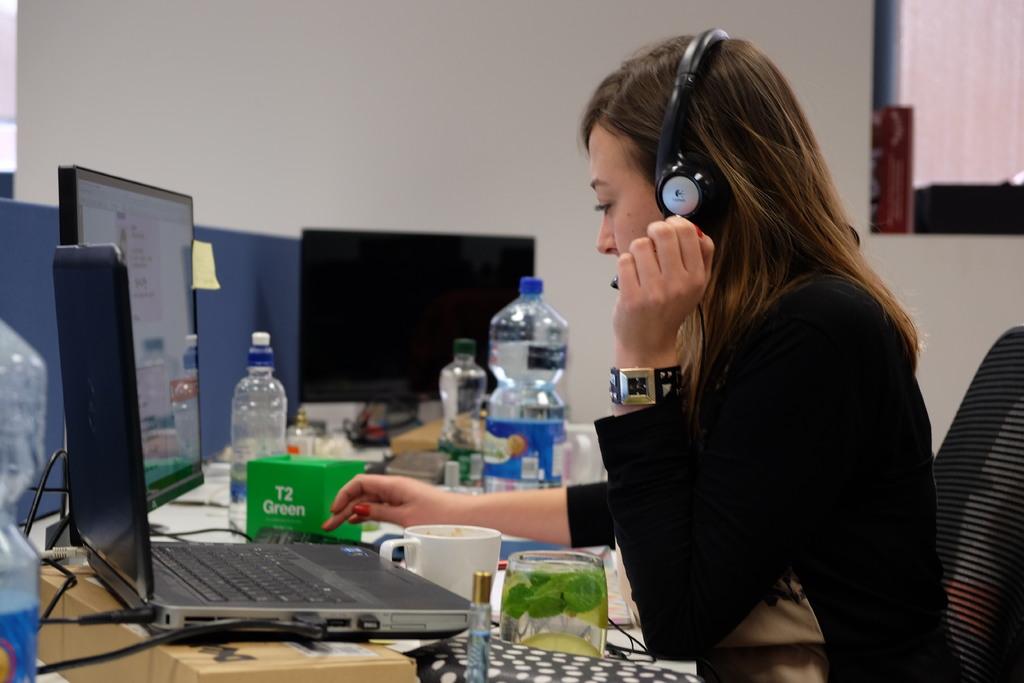What is written on the green box?
Give a very brief answer. T2 green. What´s the brand of the headset?
Keep it short and to the point. Logitech. 